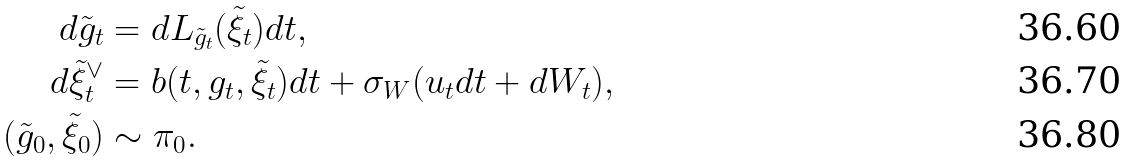Convert formula to latex. <formula><loc_0><loc_0><loc_500><loc_500>d \tilde { g } _ { t } & = d L _ { \tilde { g } _ { t } } ( \tilde { \xi } _ { t } ) d t , \\ d \tilde { \xi } _ { t } ^ { \vee } & = b ( t , g _ { t } , \tilde { \xi } _ { t } ) d t + \sigma _ { W } ( u _ { t } d t + d W _ { t } ) , \\ ( \tilde { g } _ { 0 } , \tilde { \xi } _ { 0 } ) & \sim \pi _ { 0 } .</formula> 